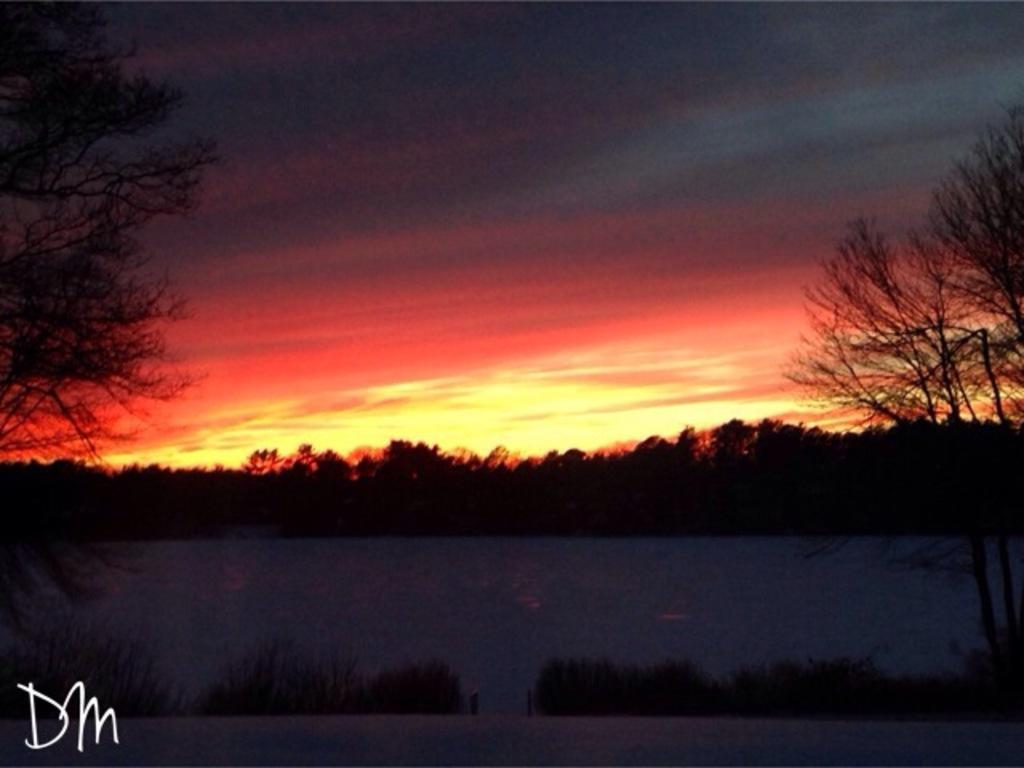Where was the image taken? The image is taken outdoors. What can be seen in the sky in the image? There is a sky with clouds in the image, and the sun is visible. What is located in the middle of the image? There are trees and plants in the middle of the image. What is the person in the image doing to express their hate towards the trip? There is no person present in the image, and therefore no action or emotion can be observed. 